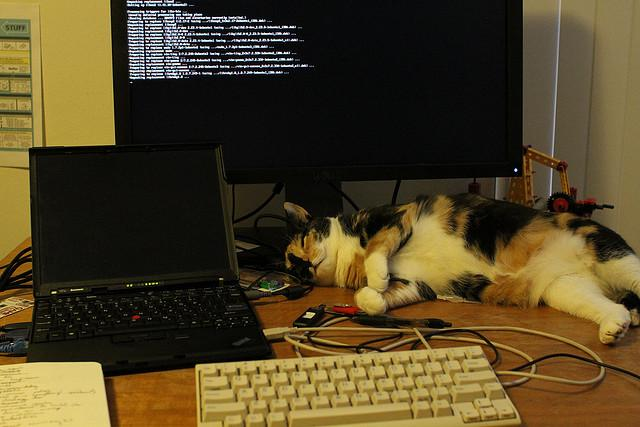What is the cat sleeping near? Please explain your reasoning. computer. The cat is by a computer. 